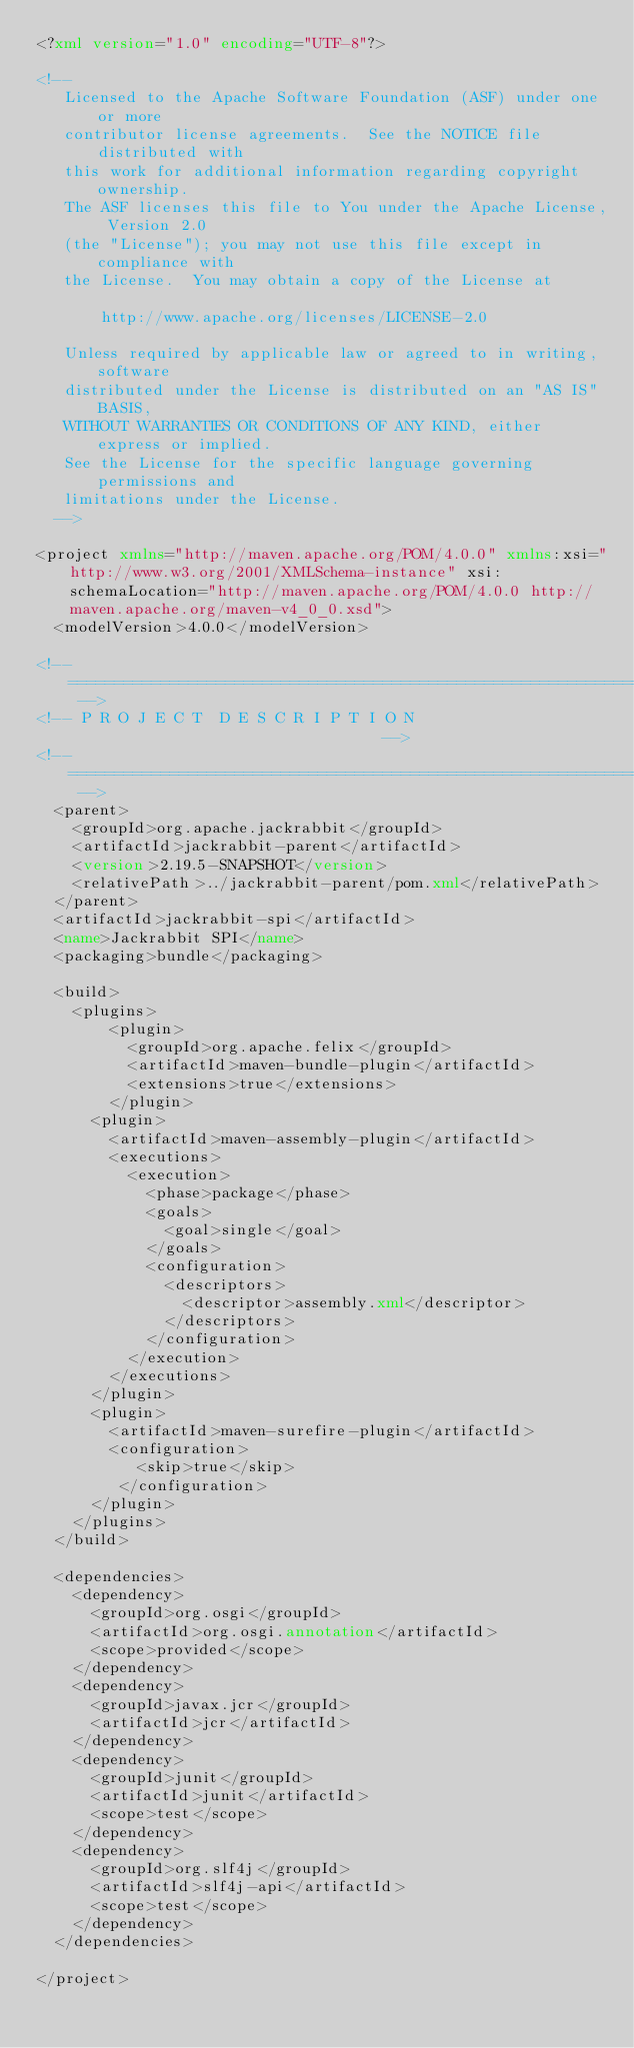Convert code to text. <code><loc_0><loc_0><loc_500><loc_500><_XML_><?xml version="1.0" encoding="UTF-8"?>

<!--
   Licensed to the Apache Software Foundation (ASF) under one or more
   contributor license agreements.  See the NOTICE file distributed with
   this work for additional information regarding copyright ownership.
   The ASF licenses this file to You under the Apache License, Version 2.0
   (the "License"); you may not use this file except in compliance with
   the License.  You may obtain a copy of the License at

       http://www.apache.org/licenses/LICENSE-2.0

   Unless required by applicable law or agreed to in writing, software
   distributed under the License is distributed on an "AS IS" BASIS,
   WITHOUT WARRANTIES OR CONDITIONS OF ANY KIND, either express or implied.
   See the License for the specific language governing permissions and
   limitations under the License.
  -->

<project xmlns="http://maven.apache.org/POM/4.0.0" xmlns:xsi="http://www.w3.org/2001/XMLSchema-instance" xsi:schemaLocation="http://maven.apache.org/POM/4.0.0 http://maven.apache.org/maven-v4_0_0.xsd">
  <modelVersion>4.0.0</modelVersion>

<!-- ====================================================================== -->
<!-- P R O J E C T  D E S C R I P T I O N                                   -->
<!-- ====================================================================== -->
  <parent>
    <groupId>org.apache.jackrabbit</groupId>
    <artifactId>jackrabbit-parent</artifactId>
    <version>2.19.5-SNAPSHOT</version>
    <relativePath>../jackrabbit-parent/pom.xml</relativePath>
  </parent>
  <artifactId>jackrabbit-spi</artifactId>
  <name>Jackrabbit SPI</name>
  <packaging>bundle</packaging>

  <build>
    <plugins>
        <plugin>
          <groupId>org.apache.felix</groupId>
          <artifactId>maven-bundle-plugin</artifactId>
          <extensions>true</extensions>
        </plugin>
      <plugin>
        <artifactId>maven-assembly-plugin</artifactId>
        <executions>
          <execution>
            <phase>package</phase>
            <goals>
              <goal>single</goal>
            </goals>
            <configuration>
              <descriptors>
                <descriptor>assembly.xml</descriptor>
              </descriptors>
            </configuration>
          </execution>
        </executions>
      </plugin>
      <plugin>
        <artifactId>maven-surefire-plugin</artifactId>
        <configuration>
           <skip>true</skip>
         </configuration>
      </plugin>
    </plugins>
  </build>
  
  <dependencies>
    <dependency>
      <groupId>org.osgi</groupId>
      <artifactId>org.osgi.annotation</artifactId>
      <scope>provided</scope>
    </dependency>
    <dependency>
      <groupId>javax.jcr</groupId>
      <artifactId>jcr</artifactId>
    </dependency>
    <dependency>
      <groupId>junit</groupId>
      <artifactId>junit</artifactId>
      <scope>test</scope>
    </dependency>
    <dependency>
      <groupId>org.slf4j</groupId>
      <artifactId>slf4j-api</artifactId>
      <scope>test</scope>
    </dependency>
  </dependencies>

</project>
</code> 